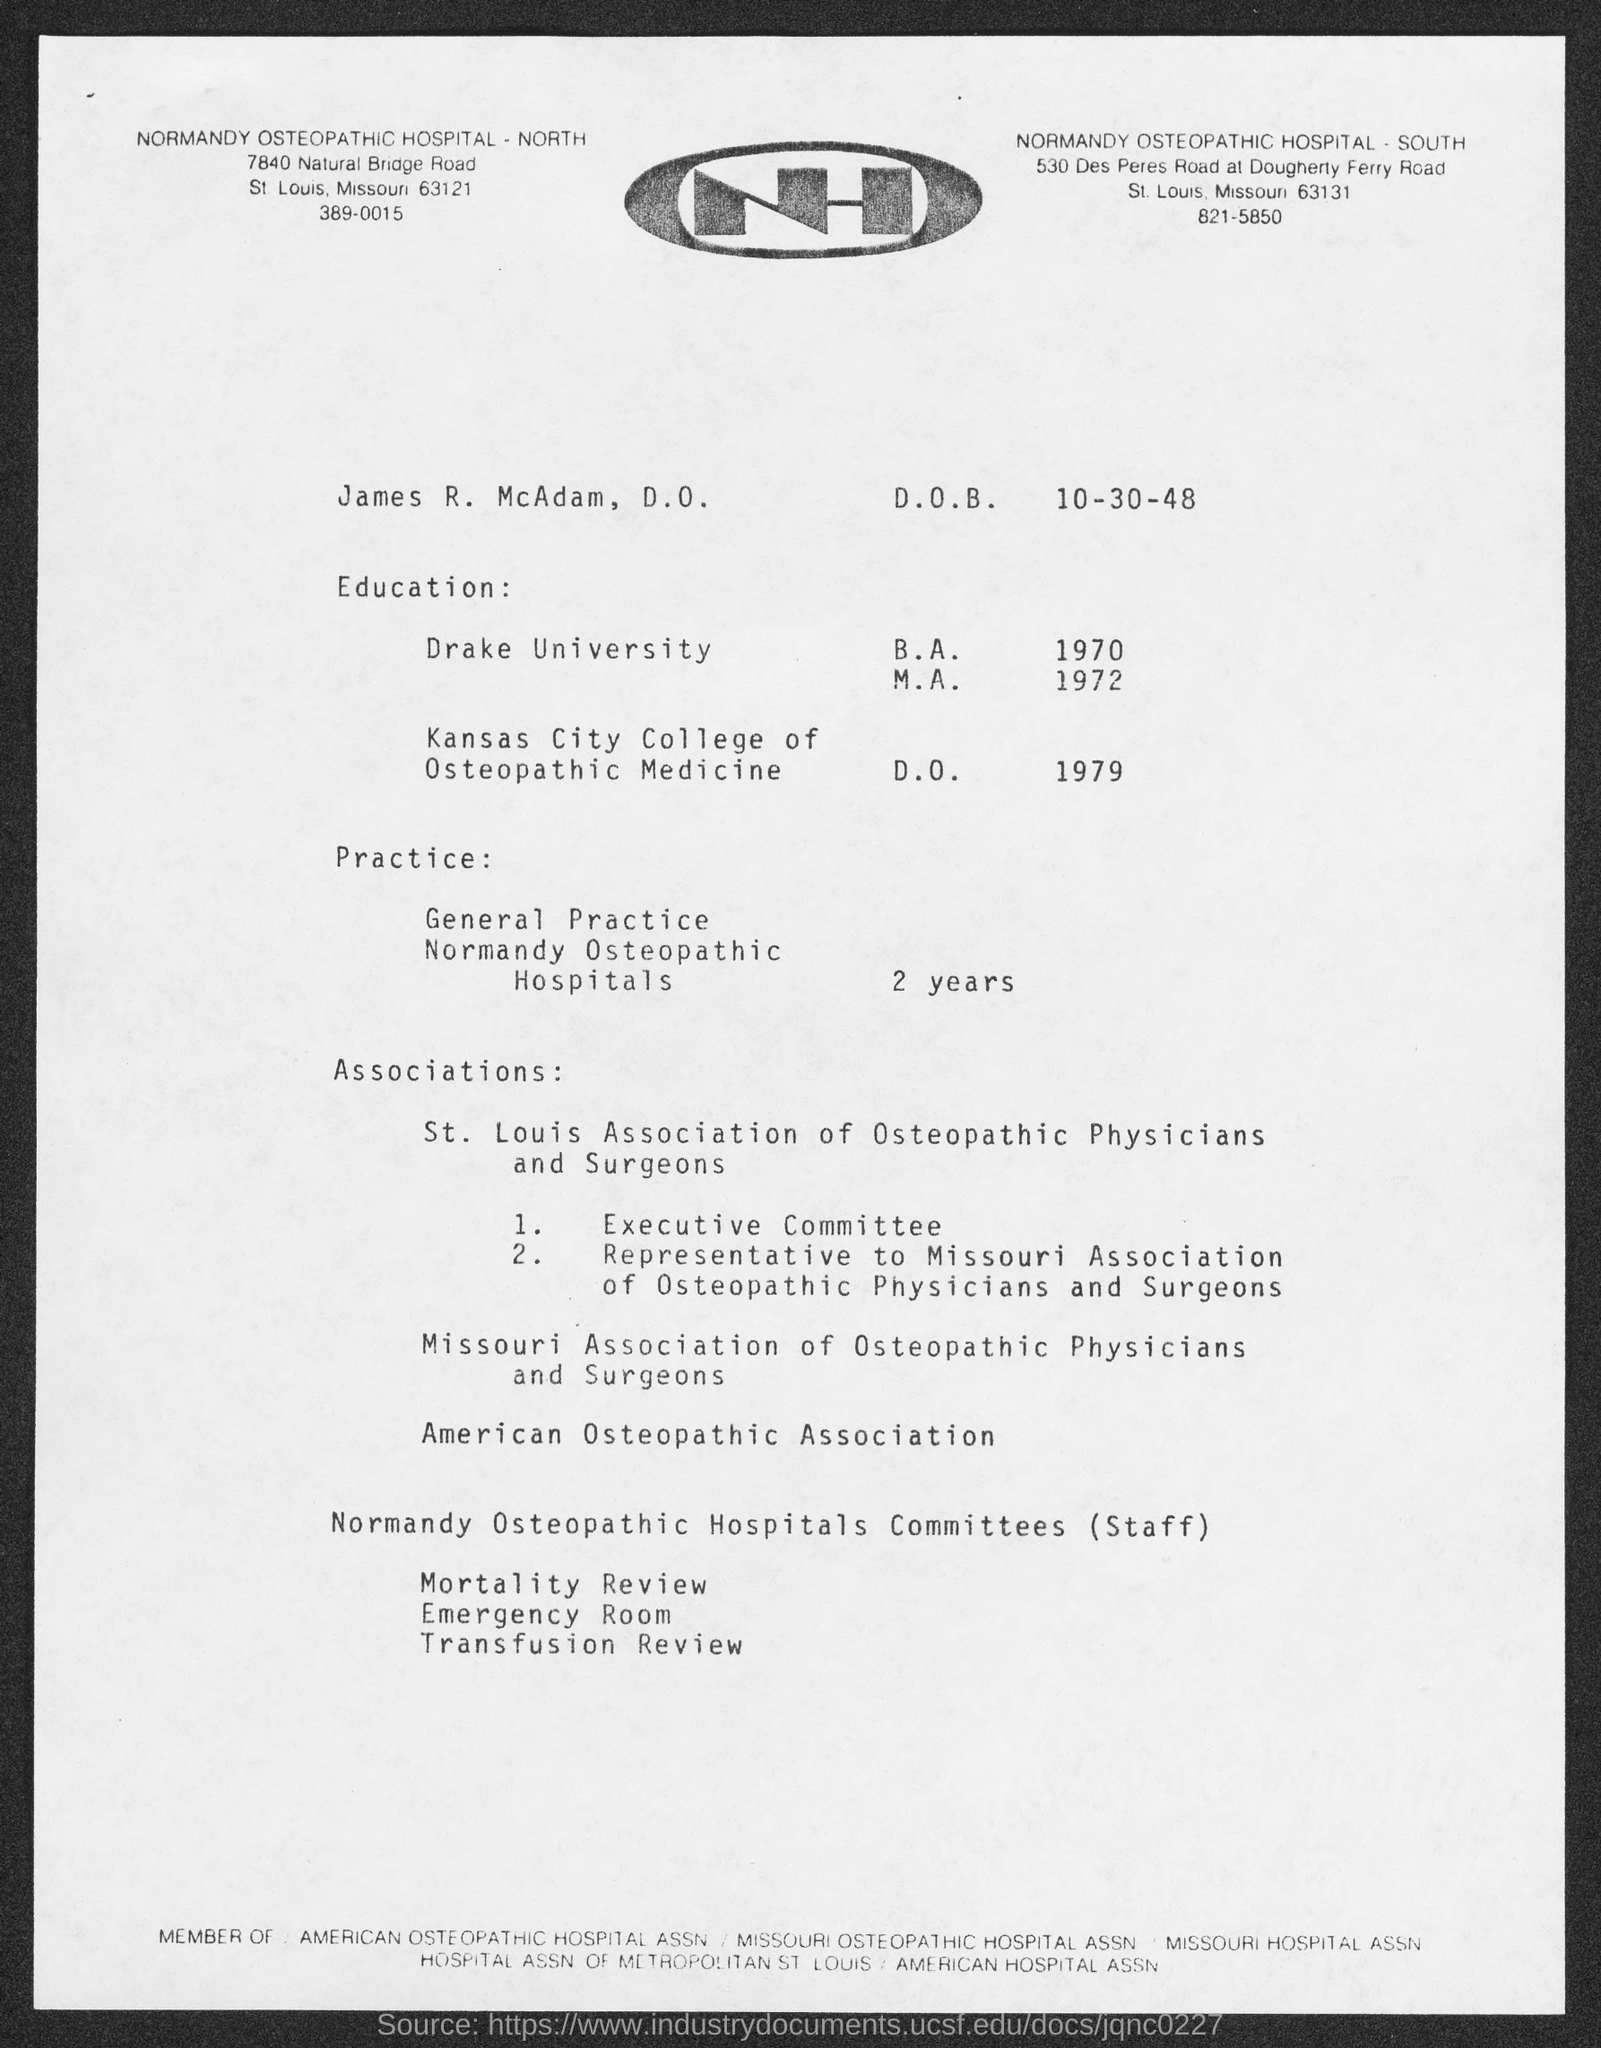Whose name is given?
Offer a terse response. James R. McAdam. What is James' D.O.B.?
Offer a very short reply. 10-30-48. From which university did James receive his B.A.?
Ensure brevity in your answer.  Drake University. In which year did James receive his D.O.?
Provide a short and direct response. 1979. For how many years did James do his General Practice at Normandy Osteopathic Hospitals?
Offer a terse response. 2. What is the telephone number of Normandy Osteopathic Hospital- North?
Ensure brevity in your answer.  389-0015. 